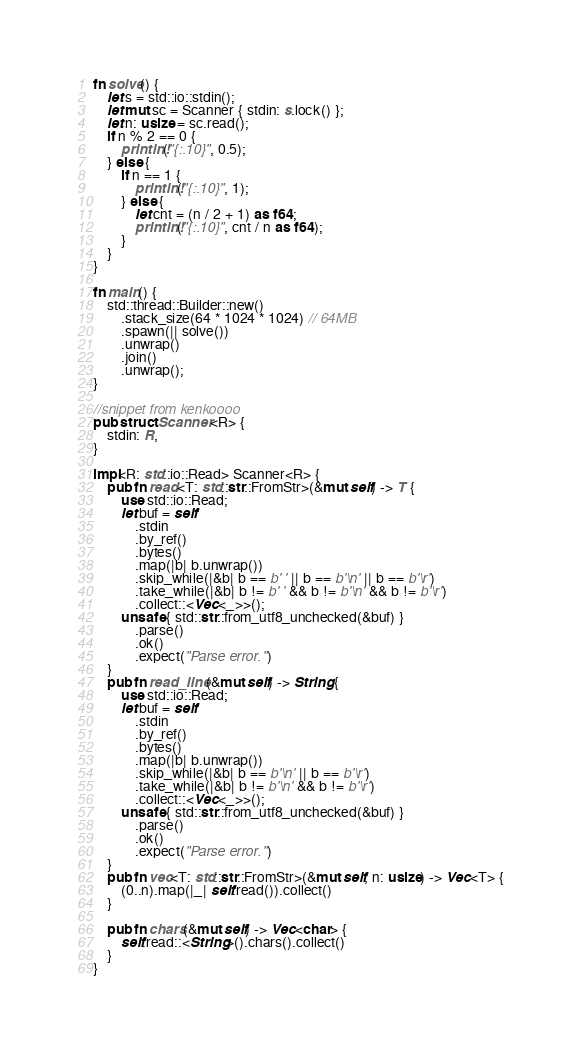Convert code to text. <code><loc_0><loc_0><loc_500><loc_500><_Rust_>fn solve() {
    let s = std::io::stdin();
    let mut sc = Scanner { stdin: s.lock() };
    let n: usize = sc.read();
    if n % 2 == 0 {
        println!("{:.10}", 0.5);
    } else {
        if n == 1 {
            println!("{:.10}", 1);
        } else {
            let cnt = (n / 2 + 1) as f64;
            println!("{:.10}", cnt / n as f64);
        }
    }
}

fn main() {
    std::thread::Builder::new()
        .stack_size(64 * 1024 * 1024) // 64MB
        .spawn(|| solve())
        .unwrap()
        .join()
        .unwrap();
}

//snippet from kenkoooo
pub struct Scanner<R> {
    stdin: R,
}

impl<R: std::io::Read> Scanner<R> {
    pub fn read<T: std::str::FromStr>(&mut self) -> T {
        use std::io::Read;
        let buf = self
            .stdin
            .by_ref()
            .bytes()
            .map(|b| b.unwrap())
            .skip_while(|&b| b == b' ' || b == b'\n' || b == b'\r')
            .take_while(|&b| b != b' ' && b != b'\n' && b != b'\r')
            .collect::<Vec<_>>();
        unsafe { std::str::from_utf8_unchecked(&buf) }
            .parse()
            .ok()
            .expect("Parse error.")
    }
    pub fn read_line(&mut self) -> String {
        use std::io::Read;
        let buf = self
            .stdin
            .by_ref()
            .bytes()
            .map(|b| b.unwrap())
            .skip_while(|&b| b == b'\n' || b == b'\r')
            .take_while(|&b| b != b'\n' && b != b'\r')
            .collect::<Vec<_>>();
        unsafe { std::str::from_utf8_unchecked(&buf) }
            .parse()
            .ok()
            .expect("Parse error.")
    }
    pub fn vec<T: std::str::FromStr>(&mut self, n: usize) -> Vec<T> {
        (0..n).map(|_| self.read()).collect()
    }

    pub fn chars(&mut self) -> Vec<char> {
        self.read::<String>().chars().collect()
    }
}
</code> 